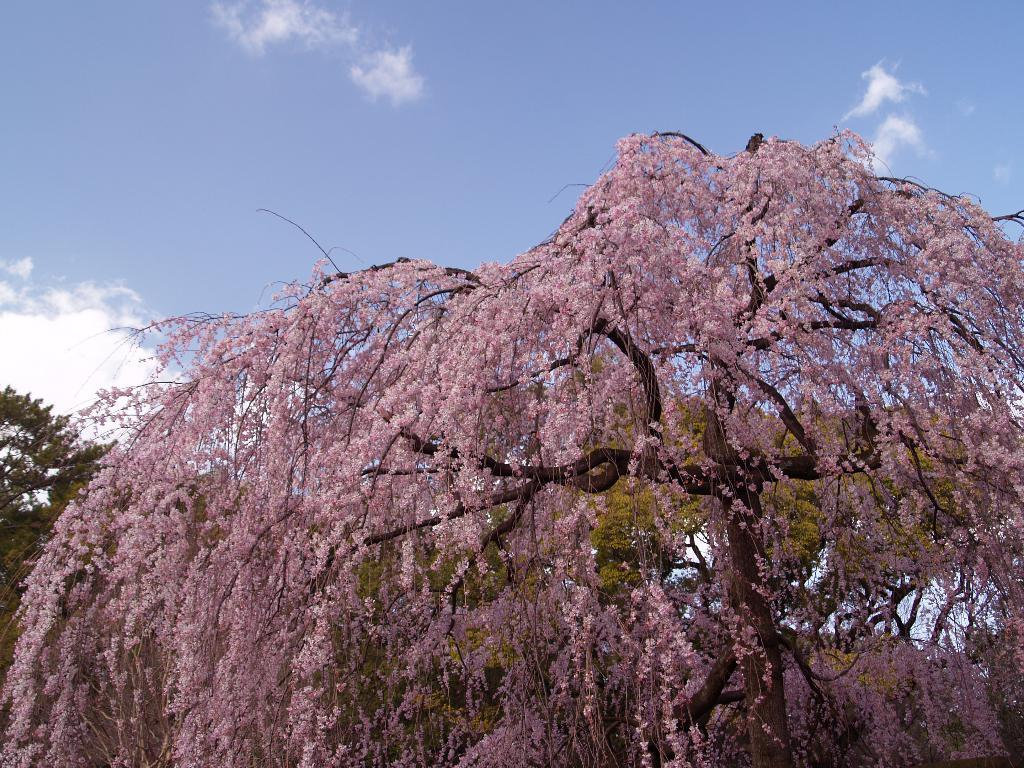What type of vegetation is in the front of the image? There are flowers in the front of the image. What type of vegetation is in the background of the image? There are trees in the background of the image. What is visible at the top of the image? The sky is visible at the top of the image. Can you tell me how many cakes are hanging from the trees in the image? There are no cakes present in the image; it features flowers in the front, trees, and the sky. What type of locket is visible on the flowers in the image? There is no locket present on the flowers in the image. 